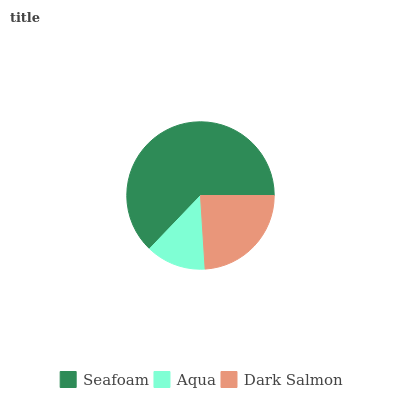Is Aqua the minimum?
Answer yes or no. Yes. Is Seafoam the maximum?
Answer yes or no. Yes. Is Dark Salmon the minimum?
Answer yes or no. No. Is Dark Salmon the maximum?
Answer yes or no. No. Is Dark Salmon greater than Aqua?
Answer yes or no. Yes. Is Aqua less than Dark Salmon?
Answer yes or no. Yes. Is Aqua greater than Dark Salmon?
Answer yes or no. No. Is Dark Salmon less than Aqua?
Answer yes or no. No. Is Dark Salmon the high median?
Answer yes or no. Yes. Is Dark Salmon the low median?
Answer yes or no. Yes. Is Seafoam the high median?
Answer yes or no. No. Is Seafoam the low median?
Answer yes or no. No. 